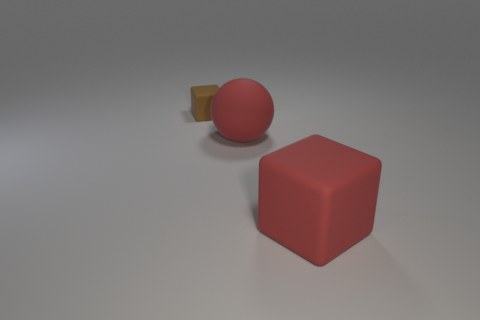How would you describe the mood or atmosphere of this scene? The scene has a minimalist and serene atmosphere with a neutral background, which highlights the simplicity of the objects. The soft lighting contributes to a calm and tranquil environment. 